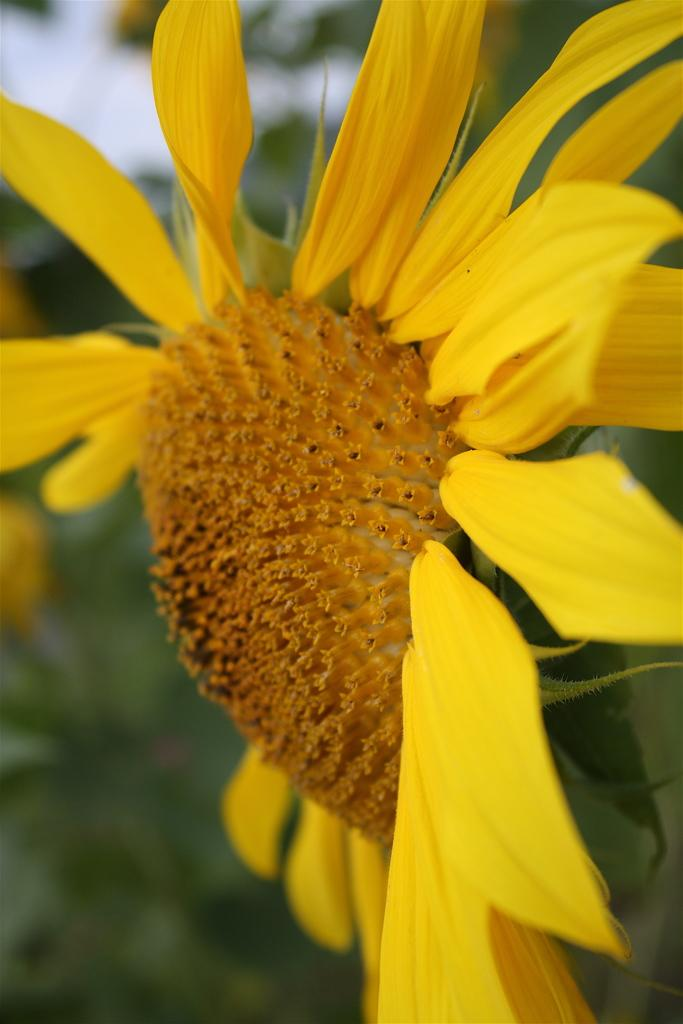What is the main subject of the image? There is a flower in the image. Where is the flower located? The flower is on a plant. What color is the flower? The flower is yellow. Can you describe the background of the image? The background of the image is blurred. What type of soup is being served in the image? There is no soup present in the image; it features a yellow flower on a plant. Are the flower's toes visible in the image? Flowers do not have toes, as they are not living beings with feet. 